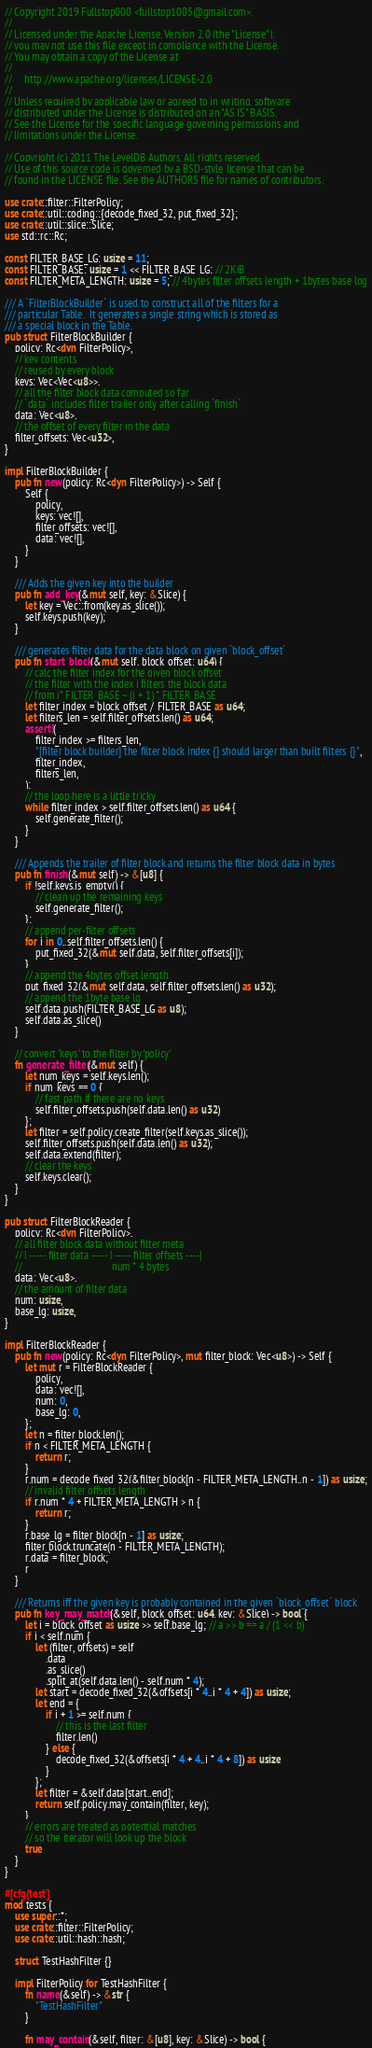Convert code to text. <code><loc_0><loc_0><loc_500><loc_500><_Rust_>// Copyright 2019 Fullstop000 <fullstop1005@gmail.com>.
//
// Licensed under the Apache License, Version 2.0 (the "License");
// you may not use this file except in compliance with the License.
// You may obtain a copy of the License at
//
//     http://www.apache.org/licenses/LICENSE-2.0
//
// Unless required by applicable law or agreed to in writing, software
// distributed under the License is distributed on an "AS IS" BASIS,
// See the License for the specific language governing permissions and
// limitations under the License.

// Copyright (c) 2011 The LevelDB Authors. All rights reserved.
// Use of this source code is governed by a BSD-style license that can be
// found in the LICENSE file. See the AUTHORS file for names of contributors.

use crate::filter::FilterPolicy;
use crate::util::coding::{decode_fixed_32, put_fixed_32};
use crate::util::slice::Slice;
use std::rc::Rc;

const FILTER_BASE_LG: usize = 11;
const FILTER_BASE: usize = 1 << FILTER_BASE_LG; // 2KiB
const FILTER_META_LENGTH: usize = 5; // 4bytes filter offsets length + 1bytes base log

/// A `FilterBlockBuilder` is used to construct all of the filters for a
/// particular Table.  It generates a single string which is stored as
/// a special block in the Table.
pub struct FilterBlockBuilder {
    policy: Rc<dyn FilterPolicy>,
    // key contents
    // reused by every block
    keys: Vec<Vec<u8>>,
    // all the filter block data computed so far
    // `data` includes filter trailer only after calling `finish`
    data: Vec<u8>,
    // the offset of every filter in the data
    filter_offsets: Vec<u32>,
}

impl FilterBlockBuilder {
    pub fn new(policy: Rc<dyn FilterPolicy>) -> Self {
        Self {
            policy,
            keys: vec![],
            filter_offsets: vec![],
            data: vec![],
        }
    }

    /// Adds the given key into the builder
    pub fn add_key(&mut self, key: &Slice) {
        let key = Vec::from(key.as_slice());
        self.keys.push(key);
    }

    /// generates filter data for the data block on given `block_offset`
    pub fn start_block(&mut self, block_offset: u64) {
        // calc the filter index for the given block offset
        // the filter with the index i filters the block data
        // from i* FILTER_BASE ~ (i + 1) * FILTER_BASE
        let filter_index = block_offset / FILTER_BASE as u64;
        let filters_len = self.filter_offsets.len() as u64;
        assert!(
            filter_index >= filters_len,
            "[filter block builder] the filter block index {} should larger than built filters {}",
            filter_index,
            filters_len,
        );
        // the loop here is a little tricky
        while filter_index > self.filter_offsets.len() as u64 {
            self.generate_filter();
        }
    }

    /// Appends the trailer of filter block and returns the filter block data in bytes
    pub fn finish(&mut self) -> &[u8] {
        if !self.keys.is_empty() {
            // clean up the remaining keys
            self.generate_filter();
        };
        // append per-filter offsets
        for i in 0..self.filter_offsets.len() {
            put_fixed_32(&mut self.data, self.filter_offsets[i]);
        }
        // append the 4bytes offset length
        put_fixed_32(&mut self.data, self.filter_offsets.len() as u32);
        // append the 1byte base lg
        self.data.push(FILTER_BASE_LG as u8);
        self.data.as_slice()
    }

    // convert 'keys' to the filter by 'policy'
    fn generate_filter(&mut self) {
        let num_keys = self.keys.len();
        if num_keys == 0 {
            // fast path if there are no keys
            self.filter_offsets.push(self.data.len() as u32)
        };
        let filter = self.policy.create_filter(self.keys.as_slice());
        self.filter_offsets.push(self.data.len() as u32);
        self.data.extend(filter);
        // clear the keys
        self.keys.clear();
    }
}

pub struct FilterBlockReader {
    policy: Rc<dyn FilterPolicy>,
    // all filter block data without filter meta
    // | ----- filter data ----- | ----- filter offsets ----|
    //                                   num * 4 bytes
    data: Vec<u8>,
    // the amount of filter data
    num: usize,
    base_lg: usize,
}

impl FilterBlockReader {
    pub fn new(policy: Rc<dyn FilterPolicy>, mut filter_block: Vec<u8>) -> Self {
        let mut r = FilterBlockReader {
            policy,
            data: vec![],
            num: 0,
            base_lg: 0,
        };
        let n = filter_block.len();
        if n < FILTER_META_LENGTH {
            return r;
        }
        r.num = decode_fixed_32(&filter_block[n - FILTER_META_LENGTH..n - 1]) as usize;
        // invalid filter offsets length
        if r.num * 4 + FILTER_META_LENGTH > n {
            return r;
        }
        r.base_lg = filter_block[n - 1] as usize;
        filter_block.truncate(n - FILTER_META_LENGTH);
        r.data = filter_block;
        r
    }

    /// Returns iff the given key is probably contained in the given `block_offset` block
    pub fn key_may_match(&self, block_offset: u64, key: &Slice) -> bool {
        let i = block_offset as usize >> self.base_lg; // a >> b == a / (1 << b)
        if i < self.num {
            let (filter, offsets) = self
                .data
                .as_slice()
                .split_at(self.data.len() - self.num * 4);
            let start = decode_fixed_32(&offsets[i * 4..i * 4 + 4]) as usize;
            let end = {
                if i + 1 >= self.num {
                    // this is the last filter
                    filter.len()
                } else {
                    decode_fixed_32(&offsets[i * 4 + 4..i * 4 + 8]) as usize
                }
            };
            let filter = &self.data[start..end];
            return self.policy.may_contain(filter, key);
        }
        // errors are treated as potential matches
        // so the iterator will look up the block
        true
    }
}

#[cfg(test)]
mod tests {
    use super::*;
    use crate::filter::FilterPolicy;
    use crate::util::hash::hash;

    struct TestHashFilter {}

    impl FilterPolicy for TestHashFilter {
        fn name(&self) -> &str {
            "TestHashFilter"
        }

        fn may_contain(&self, filter: &[u8], key: &Slice) -> bool {</code> 